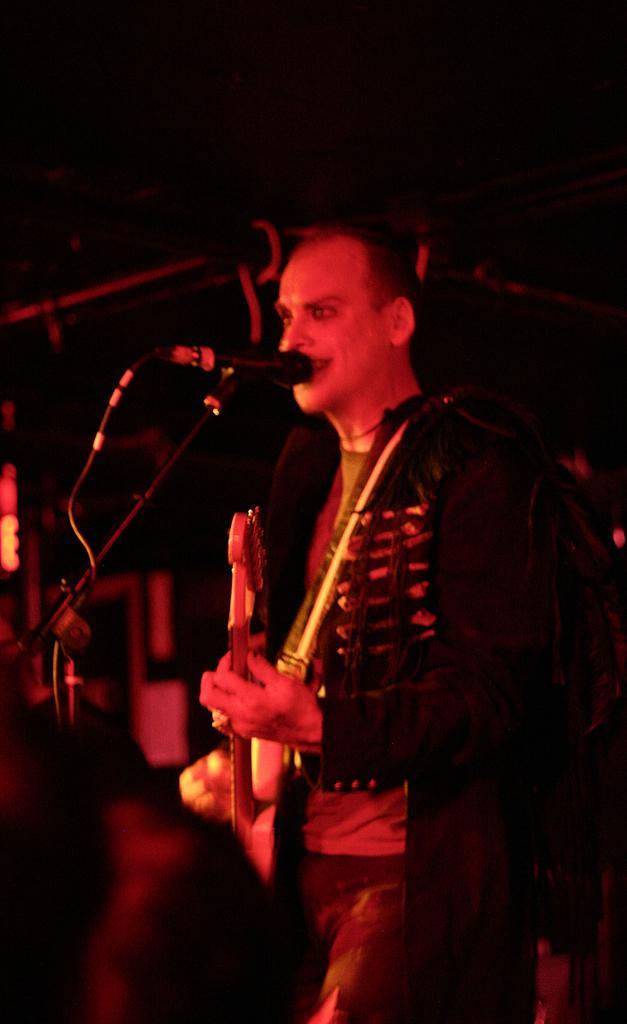Please provide a concise description of this image. In this image, there is one person standing and playing guitar and singing in front of the mike. The background of the image looks dark as if it is taken inside a hall during night time. 